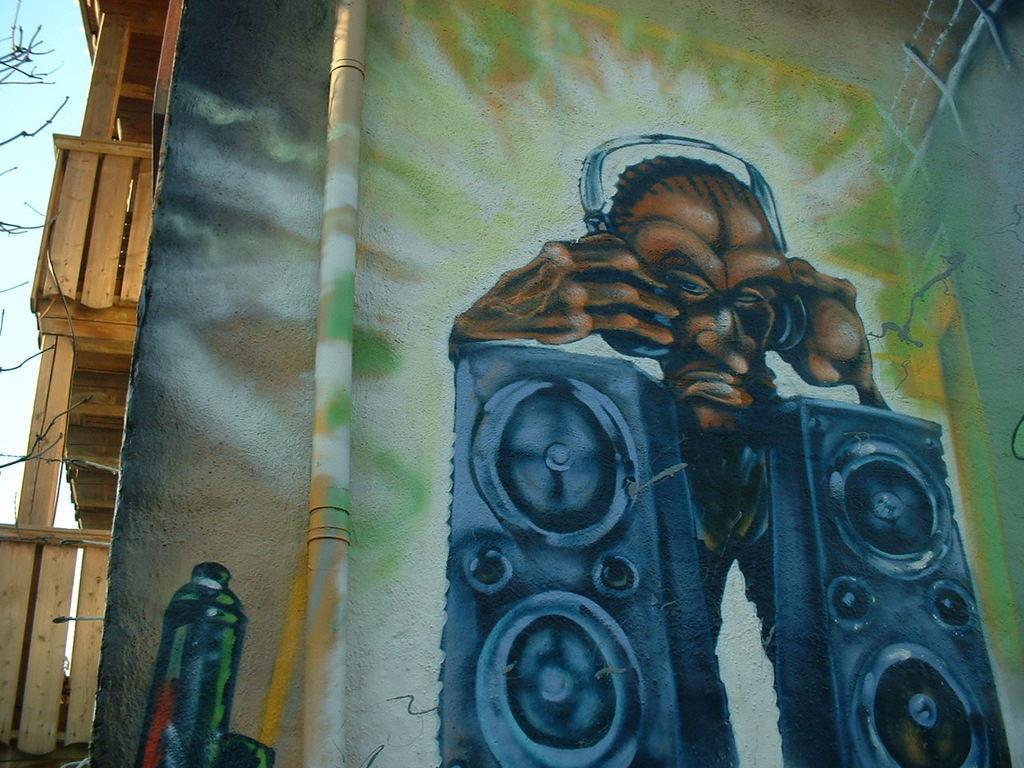In one or two sentences, can you explain what this image depicts? In this image I can see the graffiti on the wall. On the left side there are some wooden planks. In the background, I can see the sky. 